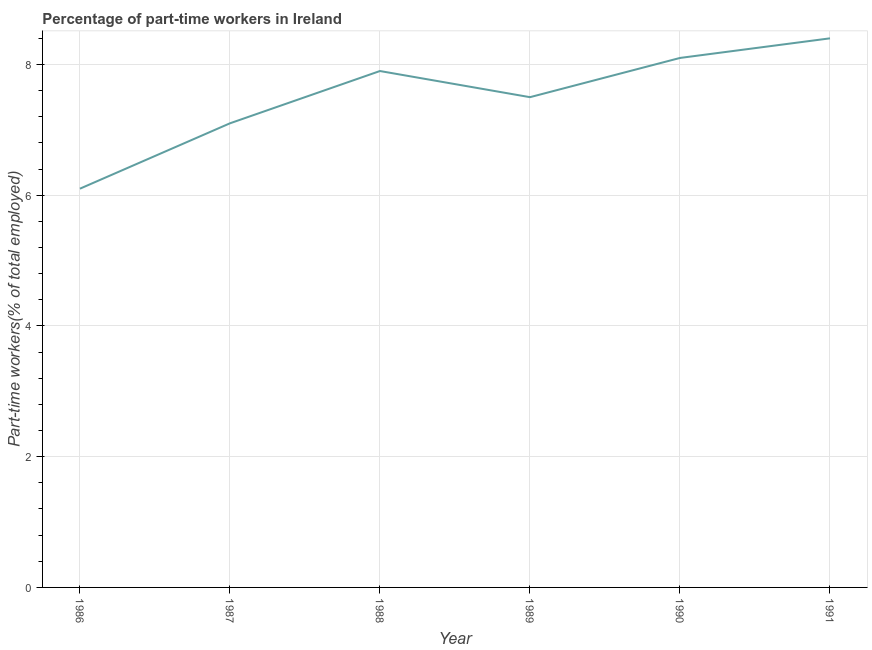What is the percentage of part-time workers in 1988?
Offer a very short reply. 7.9. Across all years, what is the maximum percentage of part-time workers?
Ensure brevity in your answer.  8.4. Across all years, what is the minimum percentage of part-time workers?
Give a very brief answer. 6.1. In which year was the percentage of part-time workers maximum?
Offer a very short reply. 1991. In which year was the percentage of part-time workers minimum?
Offer a very short reply. 1986. What is the sum of the percentage of part-time workers?
Your answer should be compact. 45.1. What is the difference between the percentage of part-time workers in 1986 and 1990?
Keep it short and to the point. -2. What is the average percentage of part-time workers per year?
Provide a succinct answer. 7.52. What is the median percentage of part-time workers?
Ensure brevity in your answer.  7.7. In how many years, is the percentage of part-time workers greater than 6 %?
Provide a short and direct response. 6. Do a majority of the years between 1990 and 1989 (inclusive) have percentage of part-time workers greater than 4.8 %?
Your answer should be very brief. No. What is the ratio of the percentage of part-time workers in 1988 to that in 1990?
Make the answer very short. 0.98. What is the difference between the highest and the second highest percentage of part-time workers?
Give a very brief answer. 0.3. Is the sum of the percentage of part-time workers in 1986 and 1990 greater than the maximum percentage of part-time workers across all years?
Provide a short and direct response. Yes. What is the difference between the highest and the lowest percentage of part-time workers?
Keep it short and to the point. 2.3. In how many years, is the percentage of part-time workers greater than the average percentage of part-time workers taken over all years?
Your response must be concise. 3. Does the percentage of part-time workers monotonically increase over the years?
Ensure brevity in your answer.  No. How many lines are there?
Offer a terse response. 1. What is the difference between two consecutive major ticks on the Y-axis?
Your response must be concise. 2. Does the graph contain grids?
Your response must be concise. Yes. What is the title of the graph?
Provide a succinct answer. Percentage of part-time workers in Ireland. What is the label or title of the Y-axis?
Your answer should be compact. Part-time workers(% of total employed). What is the Part-time workers(% of total employed) of 1986?
Provide a succinct answer. 6.1. What is the Part-time workers(% of total employed) of 1987?
Your answer should be compact. 7.1. What is the Part-time workers(% of total employed) of 1988?
Your answer should be compact. 7.9. What is the Part-time workers(% of total employed) of 1989?
Keep it short and to the point. 7.5. What is the Part-time workers(% of total employed) of 1990?
Provide a short and direct response. 8.1. What is the Part-time workers(% of total employed) of 1991?
Ensure brevity in your answer.  8.4. What is the difference between the Part-time workers(% of total employed) in 1986 and 1987?
Your answer should be compact. -1. What is the difference between the Part-time workers(% of total employed) in 1986 and 1989?
Provide a short and direct response. -1.4. What is the difference between the Part-time workers(% of total employed) in 1986 and 1990?
Your answer should be very brief. -2. What is the difference between the Part-time workers(% of total employed) in 1988 and 1989?
Make the answer very short. 0.4. What is the difference between the Part-time workers(% of total employed) in 1988 and 1991?
Keep it short and to the point. -0.5. What is the difference between the Part-time workers(% of total employed) in 1989 and 1990?
Keep it short and to the point. -0.6. What is the difference between the Part-time workers(% of total employed) in 1990 and 1991?
Make the answer very short. -0.3. What is the ratio of the Part-time workers(% of total employed) in 1986 to that in 1987?
Your answer should be very brief. 0.86. What is the ratio of the Part-time workers(% of total employed) in 1986 to that in 1988?
Provide a succinct answer. 0.77. What is the ratio of the Part-time workers(% of total employed) in 1986 to that in 1989?
Offer a very short reply. 0.81. What is the ratio of the Part-time workers(% of total employed) in 1986 to that in 1990?
Your answer should be very brief. 0.75. What is the ratio of the Part-time workers(% of total employed) in 1986 to that in 1991?
Provide a succinct answer. 0.73. What is the ratio of the Part-time workers(% of total employed) in 1987 to that in 1988?
Give a very brief answer. 0.9. What is the ratio of the Part-time workers(% of total employed) in 1987 to that in 1989?
Provide a succinct answer. 0.95. What is the ratio of the Part-time workers(% of total employed) in 1987 to that in 1990?
Keep it short and to the point. 0.88. What is the ratio of the Part-time workers(% of total employed) in 1987 to that in 1991?
Your response must be concise. 0.84. What is the ratio of the Part-time workers(% of total employed) in 1988 to that in 1989?
Provide a short and direct response. 1.05. What is the ratio of the Part-time workers(% of total employed) in 1989 to that in 1990?
Make the answer very short. 0.93. What is the ratio of the Part-time workers(% of total employed) in 1989 to that in 1991?
Your response must be concise. 0.89. What is the ratio of the Part-time workers(% of total employed) in 1990 to that in 1991?
Your response must be concise. 0.96. 